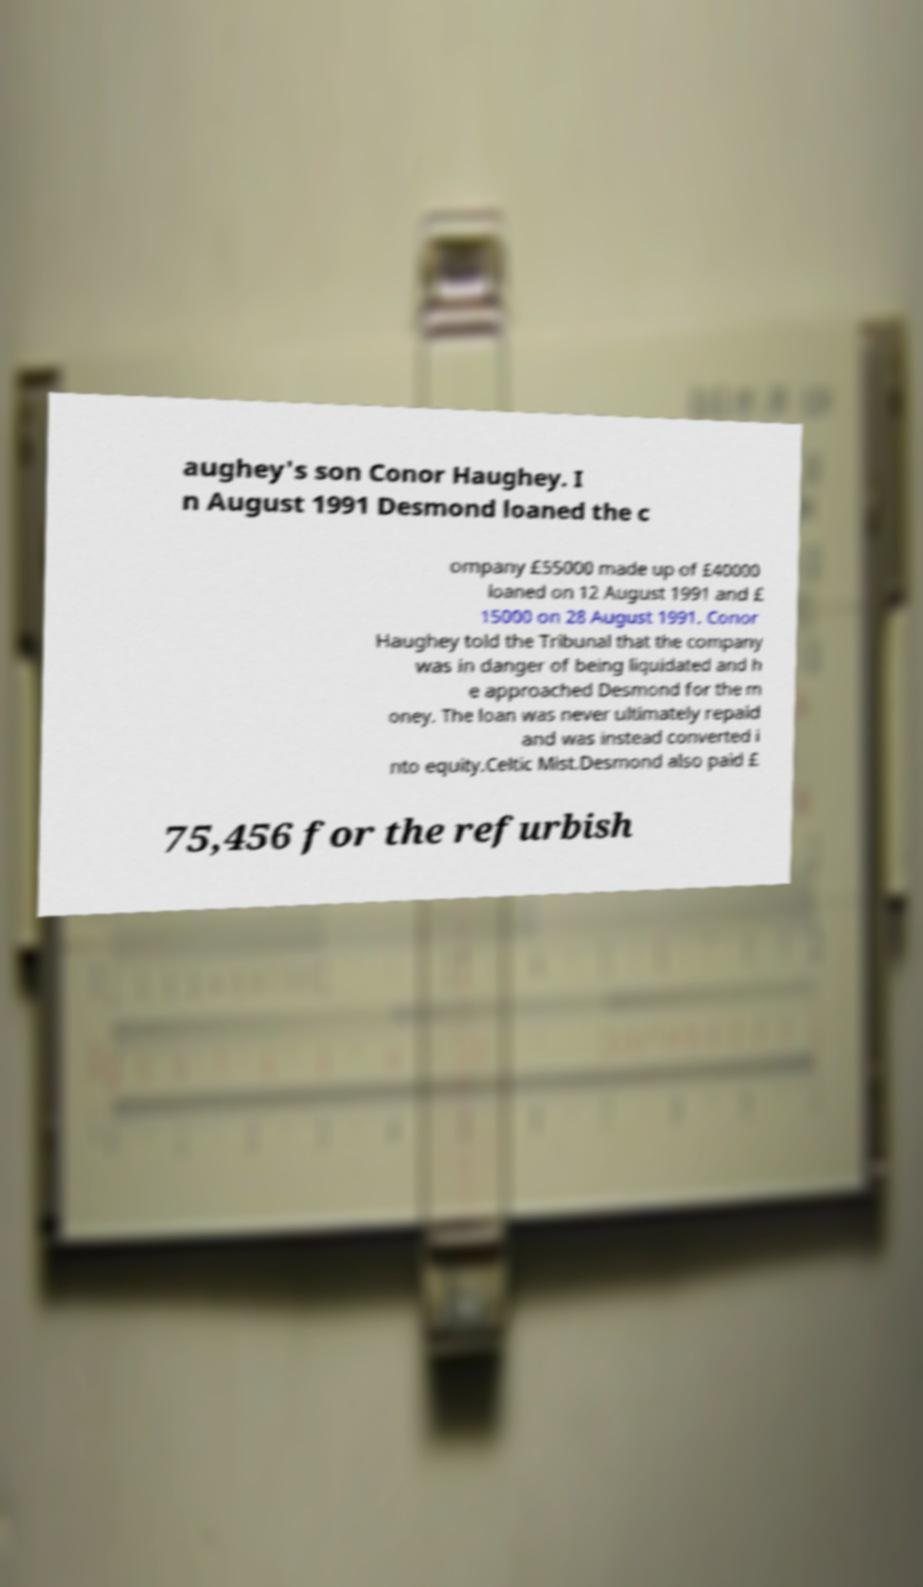Please identify and transcribe the text found in this image. aughey's son Conor Haughey. I n August 1991 Desmond loaned the c ompany £55000 made up of £40000 loaned on 12 August 1991 and £ 15000 on 28 August 1991. Conor Haughey told the Tribunal that the company was in danger of being liquidated and h e approached Desmond for the m oney. The loan was never ultimately repaid and was instead converted i nto equity.Celtic Mist.Desmond also paid £ 75,456 for the refurbish 